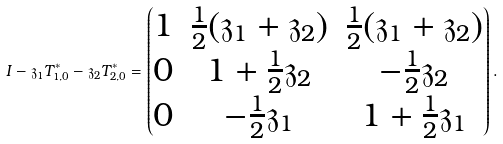Convert formula to latex. <formula><loc_0><loc_0><loc_500><loc_500>I - \mathfrak { z } _ { 1 } T _ { 1 , 0 } ^ { * } - \mathfrak { z } _ { 2 } T _ { 2 , 0 } ^ { * } = \begin{pmatrix} 1 & \frac { 1 } { 2 } ( \mathfrak { z } _ { 1 } + \mathfrak { z } _ { 2 } ) & \frac { 1 } { 2 } ( \mathfrak { z } _ { 1 } + \mathfrak { z } _ { 2 } ) \\ 0 & 1 + \frac { 1 } { 2 } \mathfrak { z } _ { 2 } & - \frac { 1 } { 2 } \mathfrak { z } _ { 2 } \\ 0 & - \frac { 1 } { 2 } \mathfrak { z } _ { 1 } & 1 + \frac { 1 } { 2 } \mathfrak { z } _ { 1 } \end{pmatrix} .</formula> 